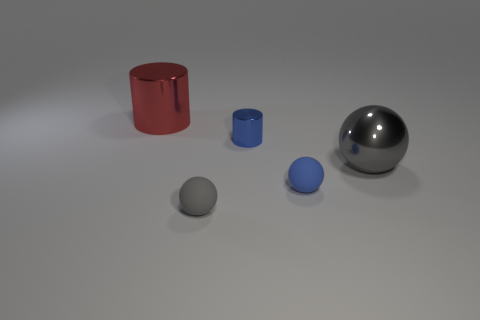Does the big gray thing have the same material as the gray sphere in front of the small blue sphere?
Offer a terse response. No. Are there more tiny blue objects that are right of the blue cylinder than purple spheres?
Provide a short and direct response. Yes. Does the small cylinder have the same color as the small rubber object that is on the right side of the small cylinder?
Provide a succinct answer. Yes. Are there an equal number of tiny cylinders behind the large cylinder and things that are left of the metallic ball?
Your answer should be compact. No. There is a big thing behind the gray shiny sphere; what is it made of?
Offer a very short reply. Metal. How many things are things to the left of the large gray thing or big cyan rubber cylinders?
Make the answer very short. 4. How many other objects are the same shape as the big gray shiny thing?
Offer a very short reply. 2. Is the shape of the tiny object in front of the small blue rubber thing the same as  the tiny blue rubber object?
Provide a short and direct response. Yes. There is a shiny sphere; are there any large gray balls behind it?
Give a very brief answer. No. How many large things are either rubber spheres or blue balls?
Make the answer very short. 0. 